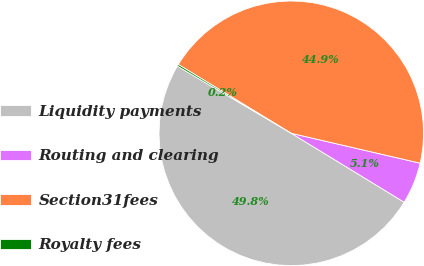Convert chart to OTSL. <chart><loc_0><loc_0><loc_500><loc_500><pie_chart><fcel>Liquidity payments<fcel>Routing and clearing<fcel>Section31fees<fcel>Royalty fees<nl><fcel>49.76%<fcel>5.1%<fcel>44.92%<fcel>0.22%<nl></chart> 